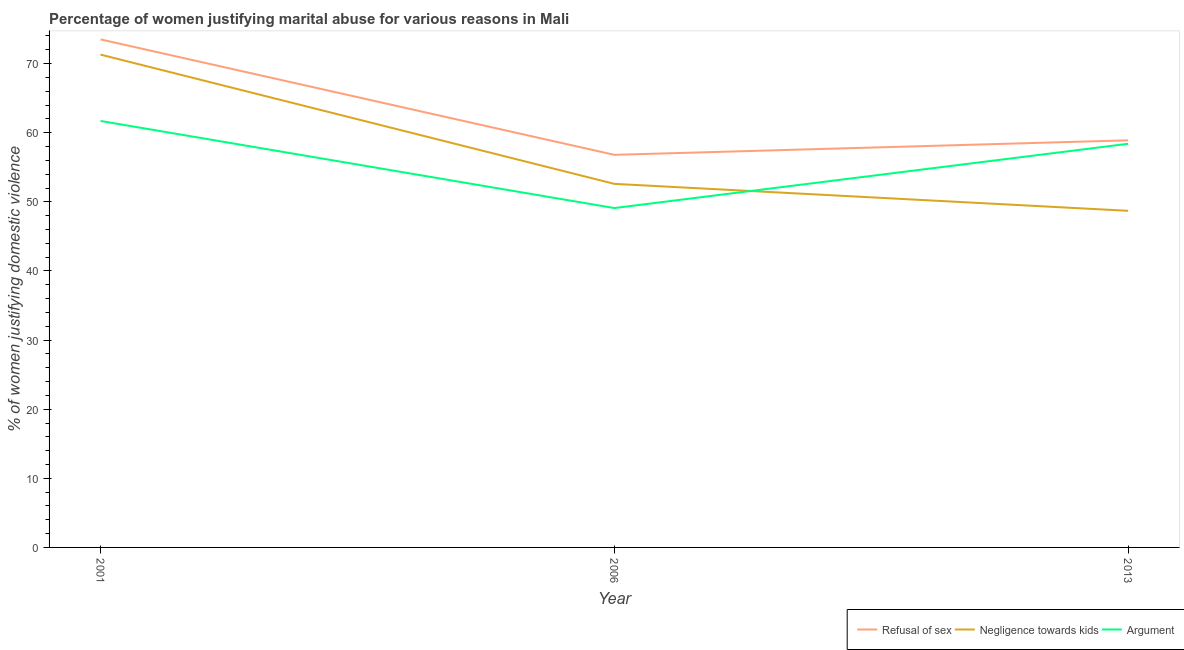Is the number of lines equal to the number of legend labels?
Provide a short and direct response. Yes. What is the percentage of women justifying domestic violence due to negligence towards kids in 2013?
Offer a very short reply. 48.7. Across all years, what is the maximum percentage of women justifying domestic violence due to refusal of sex?
Give a very brief answer. 73.5. Across all years, what is the minimum percentage of women justifying domestic violence due to refusal of sex?
Keep it short and to the point. 56.8. What is the total percentage of women justifying domestic violence due to refusal of sex in the graph?
Offer a terse response. 189.2. What is the difference between the percentage of women justifying domestic violence due to arguments in 2001 and that in 2006?
Provide a short and direct response. 12.6. What is the difference between the percentage of women justifying domestic violence due to refusal of sex in 2013 and the percentage of women justifying domestic violence due to arguments in 2006?
Your answer should be compact. 9.8. What is the average percentage of women justifying domestic violence due to refusal of sex per year?
Ensure brevity in your answer.  63.07. In the year 2001, what is the difference between the percentage of women justifying domestic violence due to refusal of sex and percentage of women justifying domestic violence due to negligence towards kids?
Your response must be concise. 2.2. What is the ratio of the percentage of women justifying domestic violence due to arguments in 2001 to that in 2013?
Offer a terse response. 1.06. Is the percentage of women justifying domestic violence due to arguments in 2001 less than that in 2006?
Ensure brevity in your answer.  No. What is the difference between the highest and the second highest percentage of women justifying domestic violence due to refusal of sex?
Make the answer very short. 14.6. What is the difference between the highest and the lowest percentage of women justifying domestic violence due to refusal of sex?
Keep it short and to the point. 16.7. Is the sum of the percentage of women justifying domestic violence due to refusal of sex in 2001 and 2006 greater than the maximum percentage of women justifying domestic violence due to arguments across all years?
Your response must be concise. Yes. Does the percentage of women justifying domestic violence due to arguments monotonically increase over the years?
Keep it short and to the point. No. Is the percentage of women justifying domestic violence due to arguments strictly less than the percentage of women justifying domestic violence due to refusal of sex over the years?
Provide a succinct answer. Yes. How many years are there in the graph?
Offer a terse response. 3. Are the values on the major ticks of Y-axis written in scientific E-notation?
Your response must be concise. No. Does the graph contain grids?
Provide a short and direct response. No. Where does the legend appear in the graph?
Give a very brief answer. Bottom right. How are the legend labels stacked?
Offer a very short reply. Horizontal. What is the title of the graph?
Offer a very short reply. Percentage of women justifying marital abuse for various reasons in Mali. Does "Total employers" appear as one of the legend labels in the graph?
Make the answer very short. No. What is the label or title of the X-axis?
Provide a short and direct response. Year. What is the label or title of the Y-axis?
Your answer should be compact. % of women justifying domestic violence. What is the % of women justifying domestic violence in Refusal of sex in 2001?
Your answer should be very brief. 73.5. What is the % of women justifying domestic violence in Negligence towards kids in 2001?
Ensure brevity in your answer.  71.3. What is the % of women justifying domestic violence in Argument in 2001?
Offer a terse response. 61.7. What is the % of women justifying domestic violence in Refusal of sex in 2006?
Your answer should be compact. 56.8. What is the % of women justifying domestic violence in Negligence towards kids in 2006?
Ensure brevity in your answer.  52.6. What is the % of women justifying domestic violence in Argument in 2006?
Provide a short and direct response. 49.1. What is the % of women justifying domestic violence of Refusal of sex in 2013?
Give a very brief answer. 58.9. What is the % of women justifying domestic violence of Negligence towards kids in 2013?
Provide a short and direct response. 48.7. What is the % of women justifying domestic violence in Argument in 2013?
Ensure brevity in your answer.  58.4. Across all years, what is the maximum % of women justifying domestic violence in Refusal of sex?
Offer a very short reply. 73.5. Across all years, what is the maximum % of women justifying domestic violence in Negligence towards kids?
Provide a short and direct response. 71.3. Across all years, what is the maximum % of women justifying domestic violence in Argument?
Offer a very short reply. 61.7. Across all years, what is the minimum % of women justifying domestic violence of Refusal of sex?
Your answer should be compact. 56.8. Across all years, what is the minimum % of women justifying domestic violence of Negligence towards kids?
Your answer should be very brief. 48.7. Across all years, what is the minimum % of women justifying domestic violence in Argument?
Offer a very short reply. 49.1. What is the total % of women justifying domestic violence in Refusal of sex in the graph?
Provide a short and direct response. 189.2. What is the total % of women justifying domestic violence in Negligence towards kids in the graph?
Your response must be concise. 172.6. What is the total % of women justifying domestic violence in Argument in the graph?
Ensure brevity in your answer.  169.2. What is the difference between the % of women justifying domestic violence of Refusal of sex in 2001 and that in 2006?
Your answer should be very brief. 16.7. What is the difference between the % of women justifying domestic violence in Negligence towards kids in 2001 and that in 2006?
Ensure brevity in your answer.  18.7. What is the difference between the % of women justifying domestic violence of Negligence towards kids in 2001 and that in 2013?
Your answer should be compact. 22.6. What is the difference between the % of women justifying domestic violence in Negligence towards kids in 2006 and that in 2013?
Make the answer very short. 3.9. What is the difference between the % of women justifying domestic violence of Argument in 2006 and that in 2013?
Your answer should be very brief. -9.3. What is the difference between the % of women justifying domestic violence in Refusal of sex in 2001 and the % of women justifying domestic violence in Negligence towards kids in 2006?
Your answer should be very brief. 20.9. What is the difference between the % of women justifying domestic violence in Refusal of sex in 2001 and the % of women justifying domestic violence in Argument in 2006?
Give a very brief answer. 24.4. What is the difference between the % of women justifying domestic violence of Negligence towards kids in 2001 and the % of women justifying domestic violence of Argument in 2006?
Provide a short and direct response. 22.2. What is the difference between the % of women justifying domestic violence of Refusal of sex in 2001 and the % of women justifying domestic violence of Negligence towards kids in 2013?
Ensure brevity in your answer.  24.8. What is the difference between the % of women justifying domestic violence of Refusal of sex in 2001 and the % of women justifying domestic violence of Argument in 2013?
Make the answer very short. 15.1. What is the difference between the % of women justifying domestic violence of Negligence towards kids in 2001 and the % of women justifying domestic violence of Argument in 2013?
Provide a succinct answer. 12.9. What is the difference between the % of women justifying domestic violence of Refusal of sex in 2006 and the % of women justifying domestic violence of Negligence towards kids in 2013?
Your response must be concise. 8.1. What is the average % of women justifying domestic violence in Refusal of sex per year?
Your answer should be very brief. 63.07. What is the average % of women justifying domestic violence of Negligence towards kids per year?
Offer a very short reply. 57.53. What is the average % of women justifying domestic violence of Argument per year?
Make the answer very short. 56.4. In the year 2001, what is the difference between the % of women justifying domestic violence of Refusal of sex and % of women justifying domestic violence of Argument?
Offer a terse response. 11.8. In the year 2013, what is the difference between the % of women justifying domestic violence in Refusal of sex and % of women justifying domestic violence in Negligence towards kids?
Give a very brief answer. 10.2. In the year 2013, what is the difference between the % of women justifying domestic violence of Refusal of sex and % of women justifying domestic violence of Argument?
Ensure brevity in your answer.  0.5. In the year 2013, what is the difference between the % of women justifying domestic violence of Negligence towards kids and % of women justifying domestic violence of Argument?
Offer a very short reply. -9.7. What is the ratio of the % of women justifying domestic violence of Refusal of sex in 2001 to that in 2006?
Your answer should be compact. 1.29. What is the ratio of the % of women justifying domestic violence in Negligence towards kids in 2001 to that in 2006?
Provide a short and direct response. 1.36. What is the ratio of the % of women justifying domestic violence of Argument in 2001 to that in 2006?
Your response must be concise. 1.26. What is the ratio of the % of women justifying domestic violence in Refusal of sex in 2001 to that in 2013?
Your answer should be very brief. 1.25. What is the ratio of the % of women justifying domestic violence in Negligence towards kids in 2001 to that in 2013?
Offer a very short reply. 1.46. What is the ratio of the % of women justifying domestic violence in Argument in 2001 to that in 2013?
Offer a terse response. 1.06. What is the ratio of the % of women justifying domestic violence of Negligence towards kids in 2006 to that in 2013?
Your response must be concise. 1.08. What is the ratio of the % of women justifying domestic violence in Argument in 2006 to that in 2013?
Ensure brevity in your answer.  0.84. What is the difference between the highest and the second highest % of women justifying domestic violence in Negligence towards kids?
Offer a terse response. 18.7. What is the difference between the highest and the second highest % of women justifying domestic violence of Argument?
Ensure brevity in your answer.  3.3. What is the difference between the highest and the lowest % of women justifying domestic violence in Refusal of sex?
Give a very brief answer. 16.7. What is the difference between the highest and the lowest % of women justifying domestic violence of Negligence towards kids?
Make the answer very short. 22.6. 